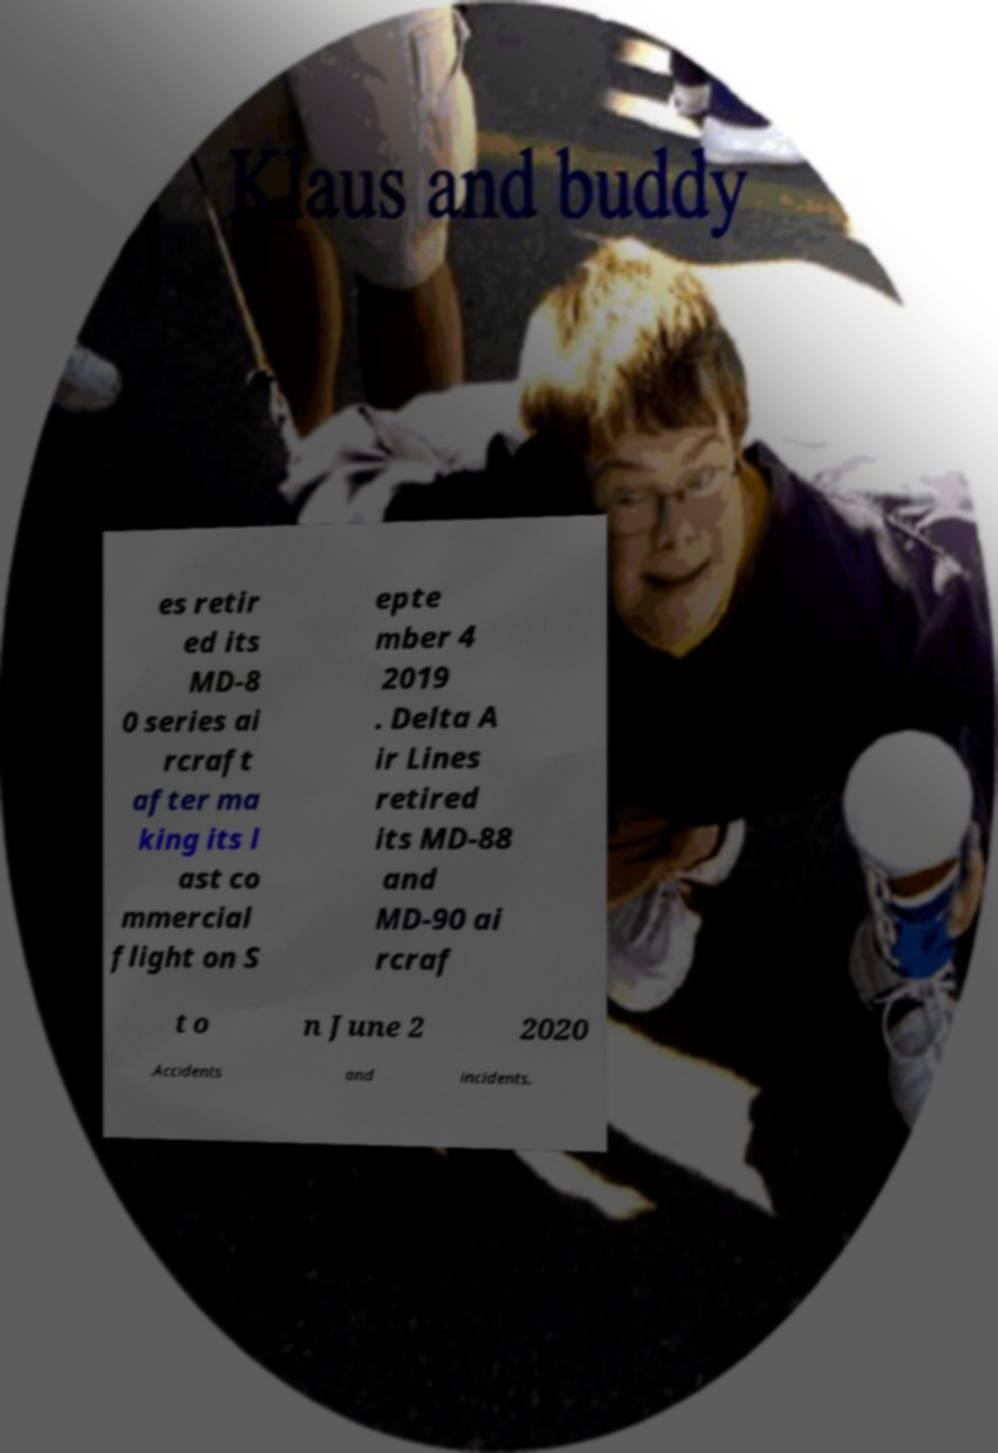Please identify and transcribe the text found in this image. es retir ed its MD-8 0 series ai rcraft after ma king its l ast co mmercial flight on S epte mber 4 2019 . Delta A ir Lines retired its MD-88 and MD-90 ai rcraf t o n June 2 2020 .Accidents and incidents. 